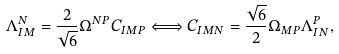Convert formula to latex. <formula><loc_0><loc_0><loc_500><loc_500>\Lambda _ { I M } ^ { N } = \frac { 2 } { \sqrt { 6 } } \Omega ^ { N P } C _ { I M P } \Longleftrightarrow C _ { I M N } = \frac { \sqrt { 6 } } { 2 } \Omega _ { M P } \Lambda _ { I N } ^ { P } ,</formula> 